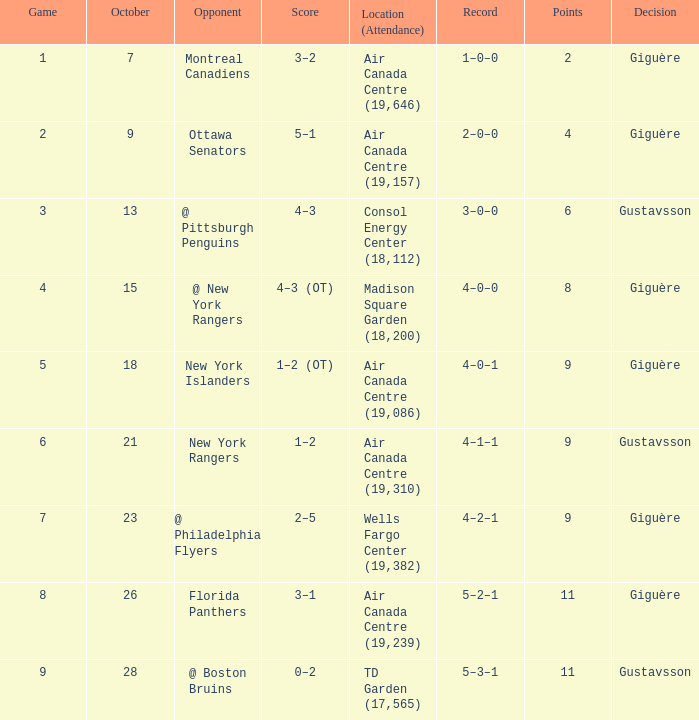What was the score for the opponent florida panthers? 1.0. Could you parse the entire table? {'header': ['Game', 'October', 'Opponent', 'Score', 'Location (Attendance)', 'Record', 'Points', 'Decision'], 'rows': [['1', '7', 'Montreal Canadiens', '3–2', 'Air Canada Centre (19,646)', '1–0–0', '2', 'Giguère'], ['2', '9', 'Ottawa Senators', '5–1', 'Air Canada Centre (19,157)', '2–0–0', '4', 'Giguère'], ['3', '13', '@ Pittsburgh Penguins', '4–3', 'Consol Energy Center (18,112)', '3–0–0', '6', 'Gustavsson'], ['4', '15', '@ New York Rangers', '4–3 (OT)', 'Madison Square Garden (18,200)', '4–0–0', '8', 'Giguère'], ['5', '18', 'New York Islanders', '1–2 (OT)', 'Air Canada Centre (19,086)', '4–0–1', '9', 'Giguère'], ['6', '21', 'New York Rangers', '1–2', 'Air Canada Centre (19,310)', '4–1–1', '9', 'Gustavsson'], ['7', '23', '@ Philadelphia Flyers', '2–5', 'Wells Fargo Center (19,382)', '4–2–1', '9', 'Giguère'], ['8', '26', 'Florida Panthers', '3–1', 'Air Canada Centre (19,239)', '5–2–1', '11', 'Giguère'], ['9', '28', '@ Boston Bruins', '0–2', 'TD Garden (17,565)', '5–3–1', '11', 'Gustavsson']]} 